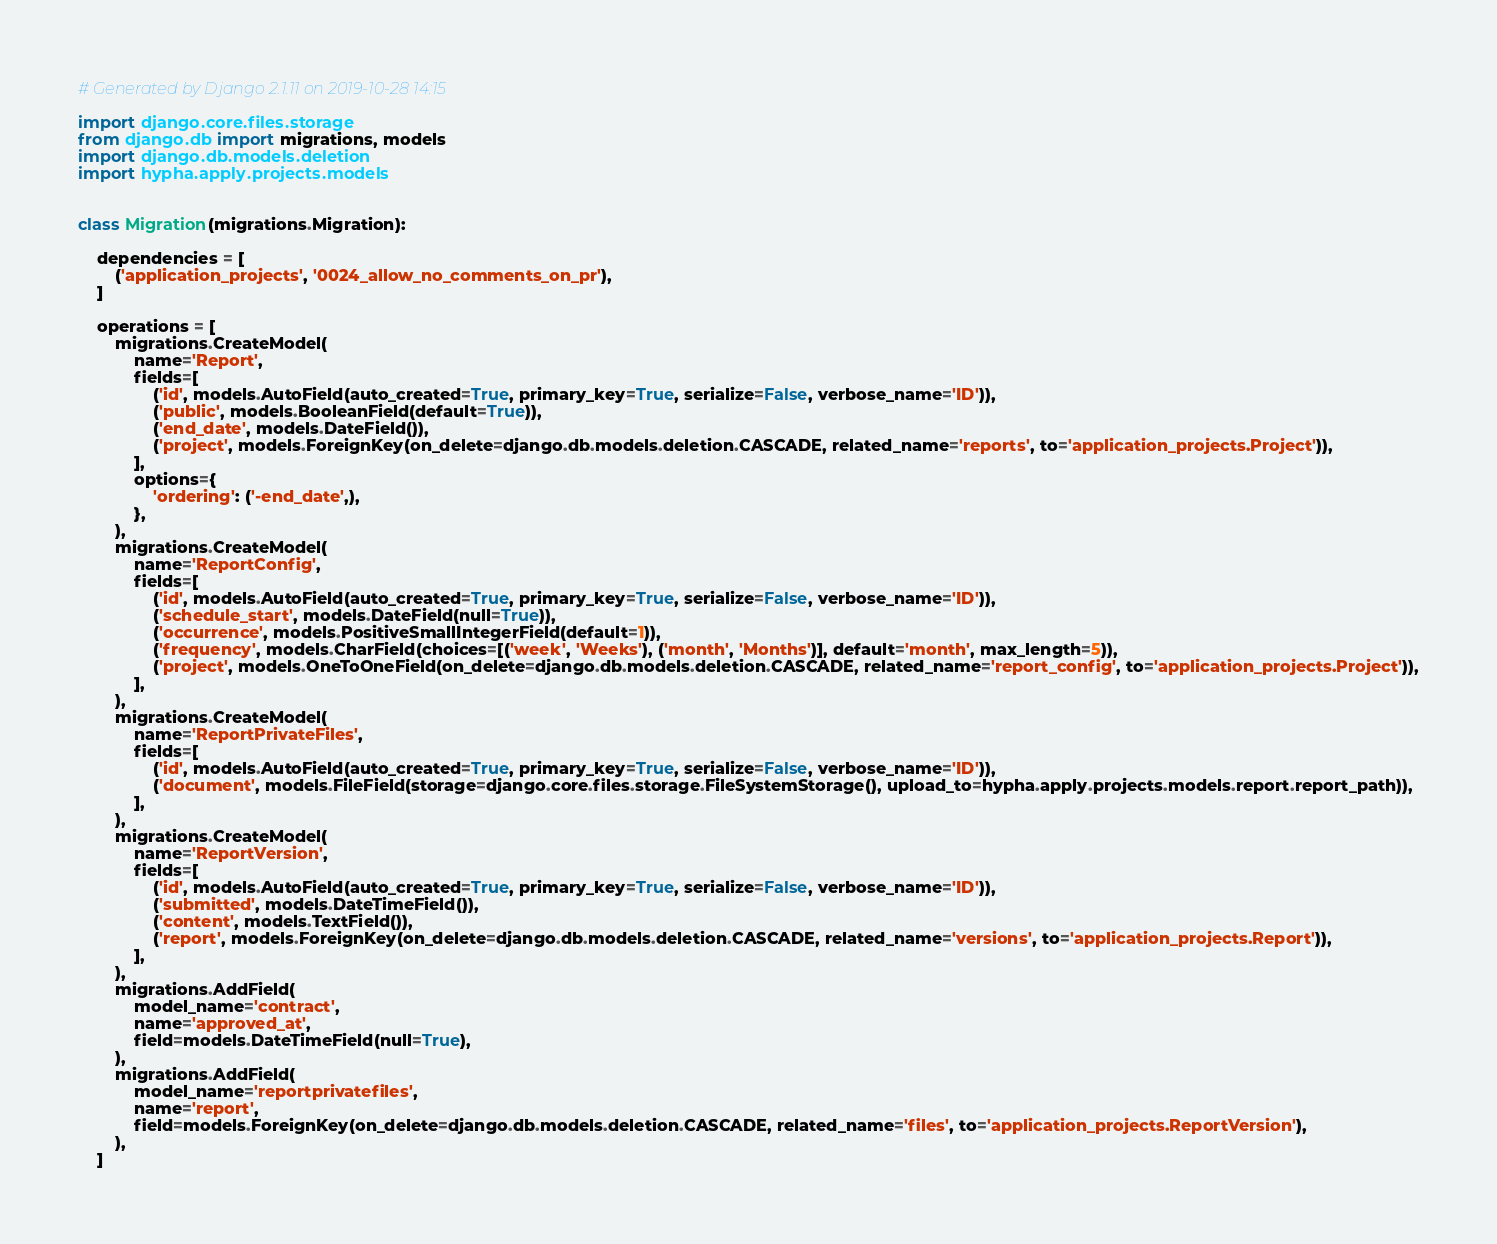<code> <loc_0><loc_0><loc_500><loc_500><_Python_># Generated by Django 2.1.11 on 2019-10-28 14:15

import django.core.files.storage
from django.db import migrations, models
import django.db.models.deletion
import hypha.apply.projects.models


class Migration(migrations.Migration):

    dependencies = [
        ('application_projects', '0024_allow_no_comments_on_pr'),
    ]

    operations = [
        migrations.CreateModel(
            name='Report',
            fields=[
                ('id', models.AutoField(auto_created=True, primary_key=True, serialize=False, verbose_name='ID')),
                ('public', models.BooleanField(default=True)),
                ('end_date', models.DateField()),
                ('project', models.ForeignKey(on_delete=django.db.models.deletion.CASCADE, related_name='reports', to='application_projects.Project')),
            ],
            options={
                'ordering': ('-end_date',),
            },
        ),
        migrations.CreateModel(
            name='ReportConfig',
            fields=[
                ('id', models.AutoField(auto_created=True, primary_key=True, serialize=False, verbose_name='ID')),
                ('schedule_start', models.DateField(null=True)),
                ('occurrence', models.PositiveSmallIntegerField(default=1)),
                ('frequency', models.CharField(choices=[('week', 'Weeks'), ('month', 'Months')], default='month', max_length=5)),
                ('project', models.OneToOneField(on_delete=django.db.models.deletion.CASCADE, related_name='report_config', to='application_projects.Project')),
            ],
        ),
        migrations.CreateModel(
            name='ReportPrivateFiles',
            fields=[
                ('id', models.AutoField(auto_created=True, primary_key=True, serialize=False, verbose_name='ID')),
                ('document', models.FileField(storage=django.core.files.storage.FileSystemStorage(), upload_to=hypha.apply.projects.models.report.report_path)),
            ],
        ),
        migrations.CreateModel(
            name='ReportVersion',
            fields=[
                ('id', models.AutoField(auto_created=True, primary_key=True, serialize=False, verbose_name='ID')),
                ('submitted', models.DateTimeField()),
                ('content', models.TextField()),
                ('report', models.ForeignKey(on_delete=django.db.models.deletion.CASCADE, related_name='versions', to='application_projects.Report')),
            ],
        ),
        migrations.AddField(
            model_name='contract',
            name='approved_at',
            field=models.DateTimeField(null=True),
        ),
        migrations.AddField(
            model_name='reportprivatefiles',
            name='report',
            field=models.ForeignKey(on_delete=django.db.models.deletion.CASCADE, related_name='files', to='application_projects.ReportVersion'),
        ),
    ]
</code> 